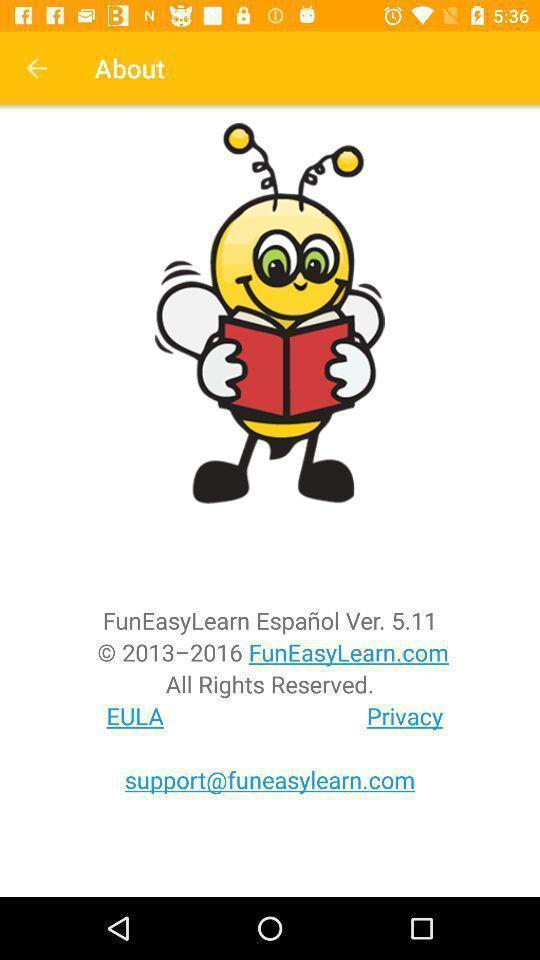What can you discern from this picture? Page that displaying information about. 